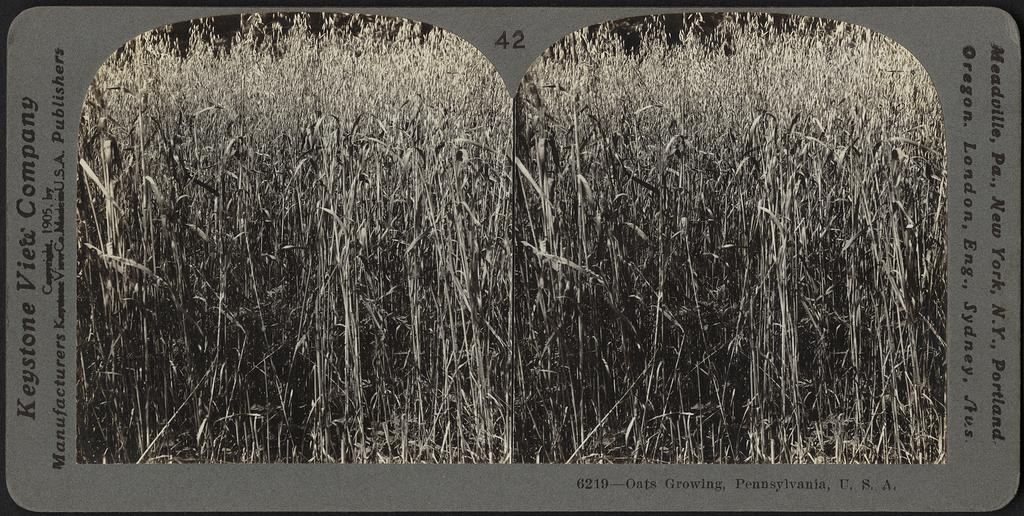What is the color scheme of the image? The image is black and white. What is the main object in the image? There is a paper with text in the image. What can be seen on the paper? There are two images of fields pasted on the paper. How many horses are drinking water from the liquid in the image? There are no horses or liquid present in the image. What type of legal advice is the lawyer providing in the image? There is no lawyer or legal advice present in the image. 